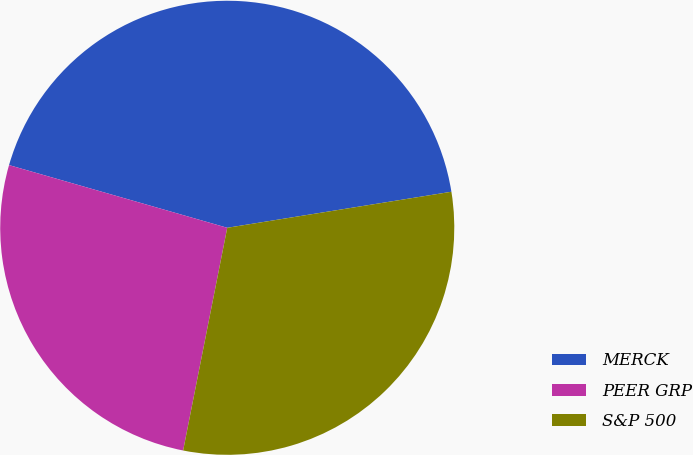Convert chart to OTSL. <chart><loc_0><loc_0><loc_500><loc_500><pie_chart><fcel>MERCK<fcel>PEER GRP<fcel>S&P 500<nl><fcel>43.01%<fcel>26.34%<fcel>30.65%<nl></chart> 